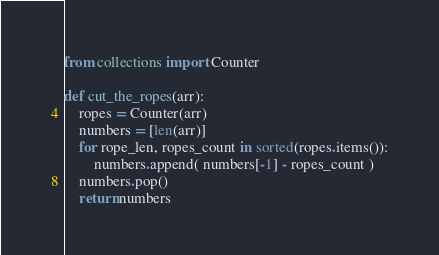Convert code to text. <code><loc_0><loc_0><loc_500><loc_500><_Python_>from collections import Counter

def cut_the_ropes(arr):
    ropes = Counter(arr)
    numbers = [len(arr)]
    for rope_len, ropes_count in sorted(ropes.items()):
        numbers.append( numbers[-1] - ropes_count )
    numbers.pop()        
    return numbers</code> 